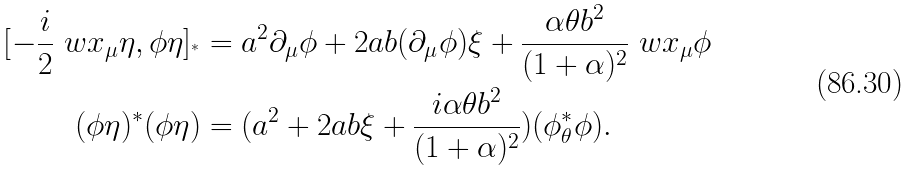<formula> <loc_0><loc_0><loc_500><loc_500>[ - \frac { i } { 2 } \ w x _ { \mu } \eta , \phi \eta ] _ { ^ { * } } & = a ^ { 2 } \partial _ { \mu } \phi + 2 a b ( \partial _ { \mu } \phi ) \xi + \frac { \alpha \theta b ^ { 2 } } { ( 1 + \alpha ) ^ { 2 } } \ w x _ { \mu } \phi \\ ( \phi \eta ) ^ { * } ( \phi \eta ) & = ( a ^ { 2 } + 2 a b \xi + \frac { i \alpha \theta b ^ { 2 } } { ( 1 + \alpha ) ^ { 2 } } ) ( \phi ^ { * } _ { \theta } \phi ) .</formula> 